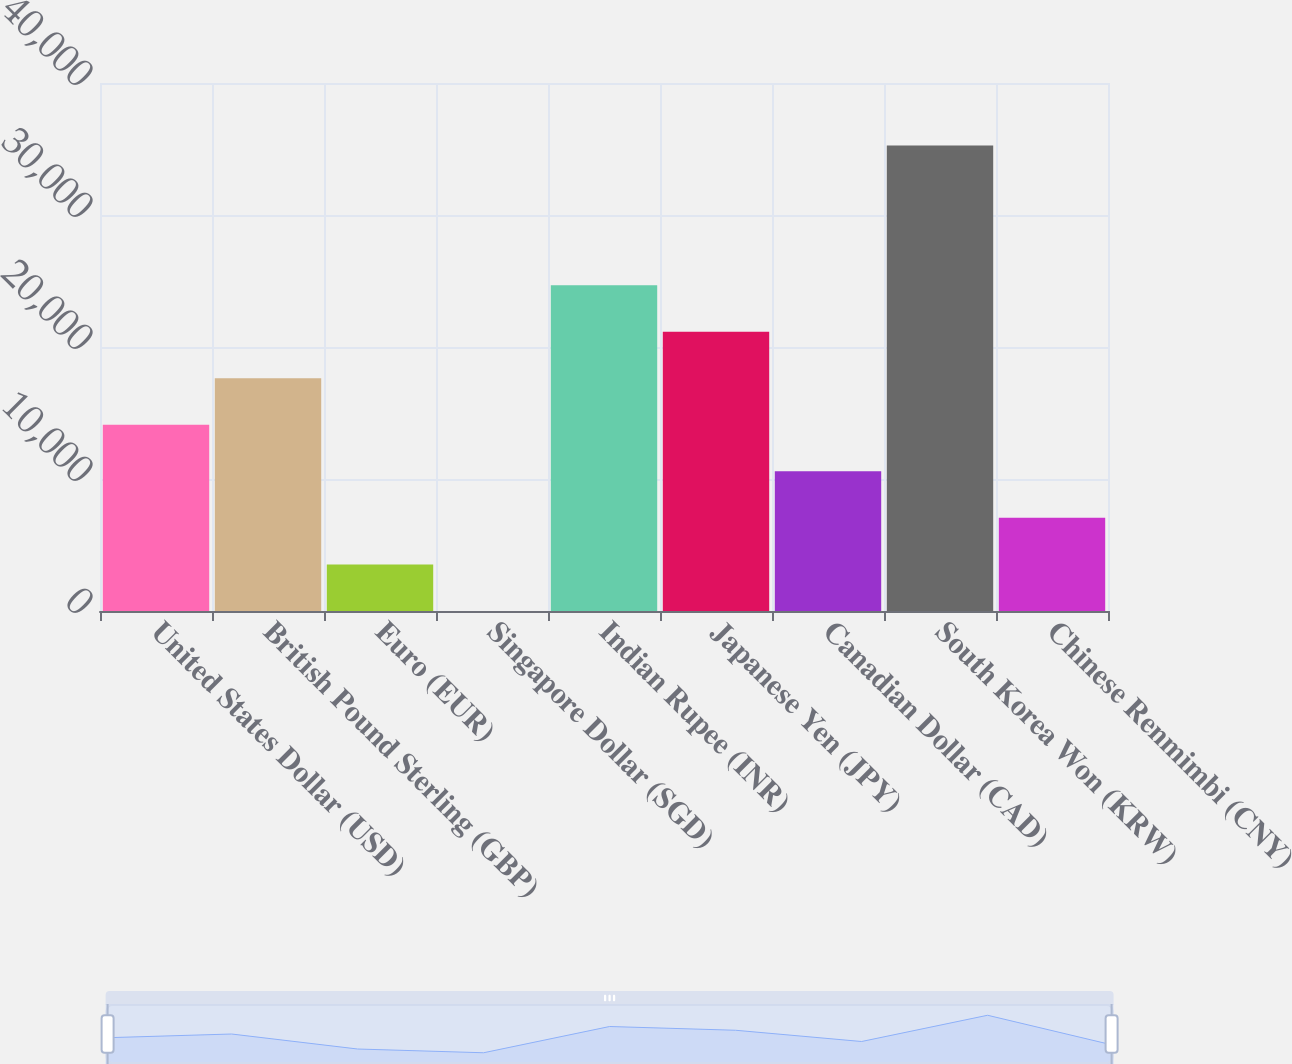Convert chart. <chart><loc_0><loc_0><loc_500><loc_500><bar_chart><fcel>United States Dollar (USD)<fcel>British Pound Sterling (GBP)<fcel>Euro (EUR)<fcel>Singapore Dollar (SGD)<fcel>Indian Rupee (INR)<fcel>Japanese Yen (JPY)<fcel>Canadian Dollar (CAD)<fcel>South Korea Won (KRW)<fcel>Chinese Renmimbi (CNY)<nl><fcel>14108.2<fcel>17634.5<fcel>3529.3<fcel>3<fcel>24687.1<fcel>21160.8<fcel>10581.9<fcel>35266<fcel>7055.6<nl></chart> 